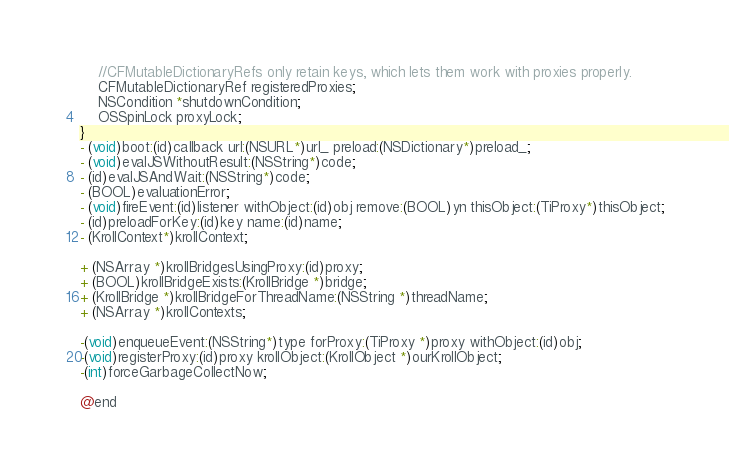<code> <loc_0><loc_0><loc_500><loc_500><_C_>	//CFMutableDictionaryRefs only retain keys, which lets them work with proxies properly.
	CFMutableDictionaryRef registeredProxies;
	NSCondition *shutdownCondition;
	OSSpinLock proxyLock;
}
- (void)boot:(id)callback url:(NSURL*)url_ preload:(NSDictionary*)preload_;
- (void)evalJSWithoutResult:(NSString*)code;
- (id)evalJSAndWait:(NSString*)code;
- (BOOL)evaluationError;
- (void)fireEvent:(id)listener withObject:(id)obj remove:(BOOL)yn thisObject:(TiProxy*)thisObject;
- (id)preloadForKey:(id)key name:(id)name;
- (KrollContext*)krollContext;

+ (NSArray *)krollBridgesUsingProxy:(id)proxy;
+ (BOOL)krollBridgeExists:(KrollBridge *)bridge;
+ (KrollBridge *)krollBridgeForThreadName:(NSString *)threadName;
+ (NSArray *)krollContexts;

-(void)enqueueEvent:(NSString*)type forProxy:(TiProxy *)proxy withObject:(id)obj;
-(void)registerProxy:(id)proxy krollObject:(KrollObject *)ourKrollObject;
-(int)forceGarbageCollectNow;

@end

</code> 